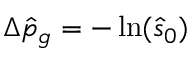<formula> <loc_0><loc_0><loc_500><loc_500>\Delta \hat { p } _ { g } = - \ln ( \hat { s } _ { 0 } )</formula> 